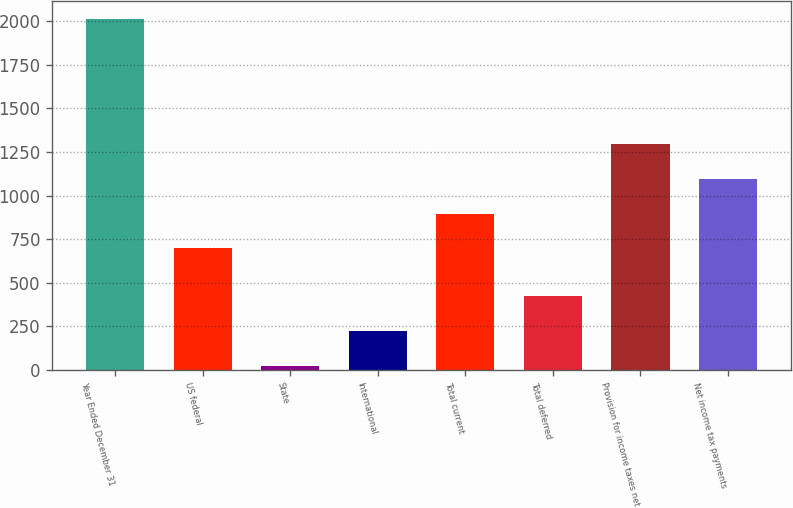<chart> <loc_0><loc_0><loc_500><loc_500><bar_chart><fcel>Year Ended December 31<fcel>US federal<fcel>State<fcel>International<fcel>Total current<fcel>Total deferred<fcel>Provision for income taxes net<fcel>Net income tax payments<nl><fcel>2016<fcel>698<fcel>24<fcel>223.2<fcel>897.2<fcel>422.4<fcel>1295.6<fcel>1096.4<nl></chart> 